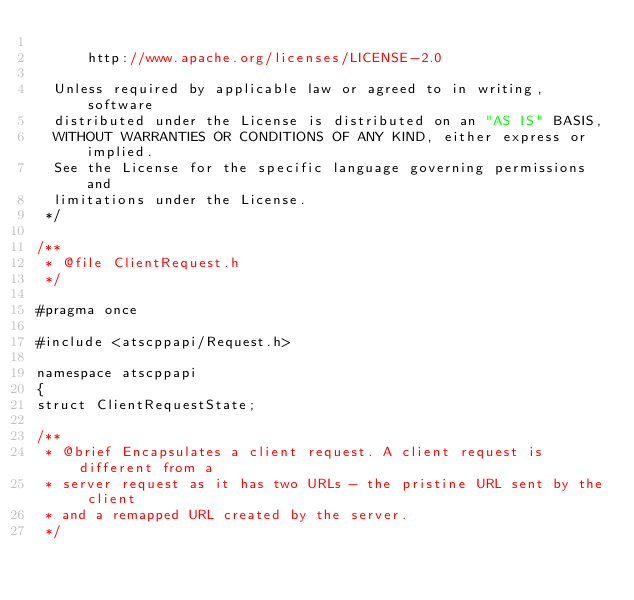Convert code to text. <code><loc_0><loc_0><loc_500><loc_500><_C_>
      http://www.apache.org/licenses/LICENSE-2.0

  Unless required by applicable law or agreed to in writing, software
  distributed under the License is distributed on an "AS IS" BASIS,
  WITHOUT WARRANTIES OR CONDITIONS OF ANY KIND, either express or implied.
  See the License for the specific language governing permissions and
  limitations under the License.
 */

/**
 * @file ClientRequest.h
 */

#pragma once

#include <atscppapi/Request.h>

namespace atscppapi
{
struct ClientRequestState;

/**
 * @brief Encapsulates a client request. A client request is different from a
 * server request as it has two URLs - the pristine URL sent by the client
 * and a remapped URL created by the server.
 */</code> 